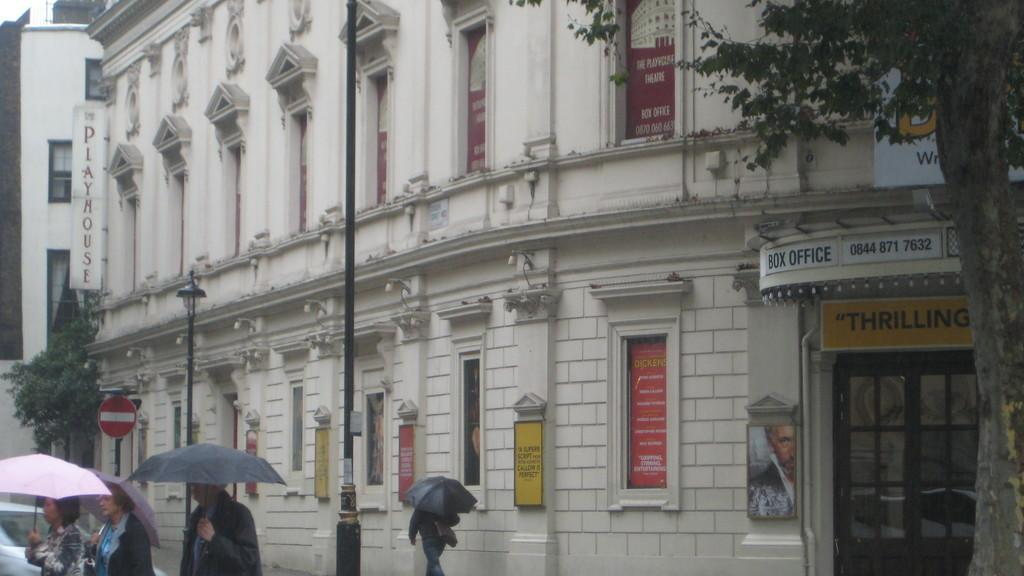Who or what is present in the image? There are people in the image. What are the people holding in the image? The people are holding umbrellas. What type of natural elements can be seen in the image? There are trees in the image. What type of artificial elements can be seen in the image? There are street lights and buildings in the image. What type of shade is provided by the building in the image? There is no specific shade provided by a building in the image, as the focus is on the people holding umbrellas. 